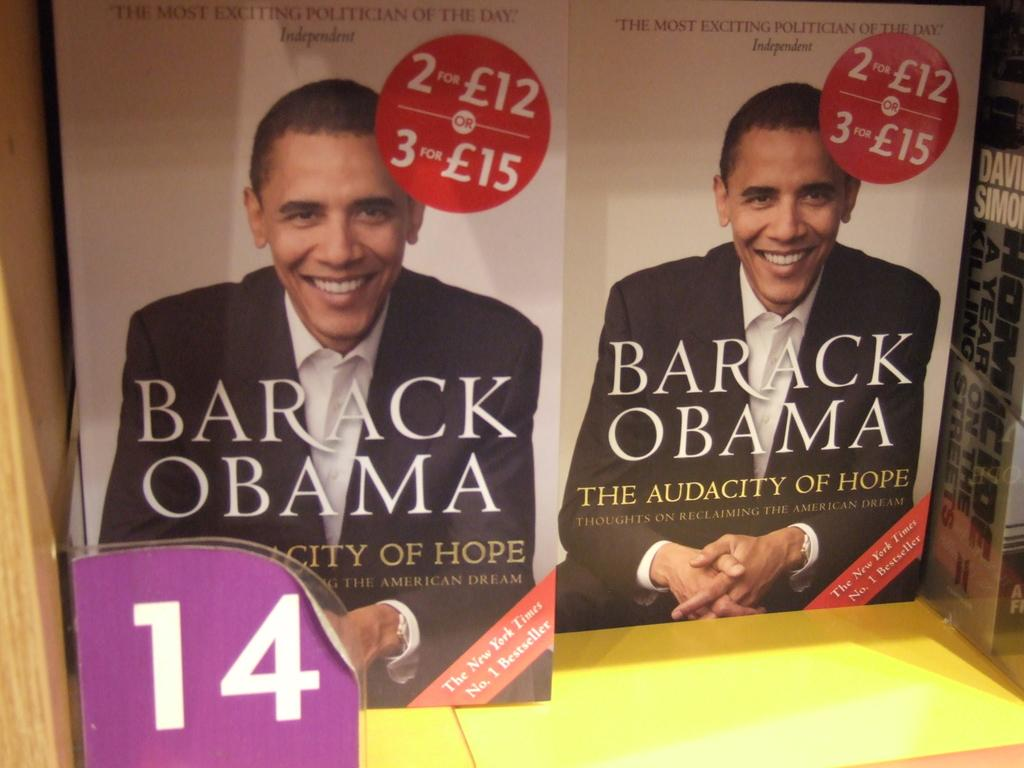What can be seen on the rack in the image? There are books on a rack in the image. What is written or depicted on the books or rack? There are images and text written on the books or rack. What type of material is the wooden object made of? The wooden object at the side of the rack is made of wood. What type of approval is required for the books to go on a voyage in the image? There is no indication of a voyage or approval process in the image; it simply shows books on a rack with a wooden object nearby. 